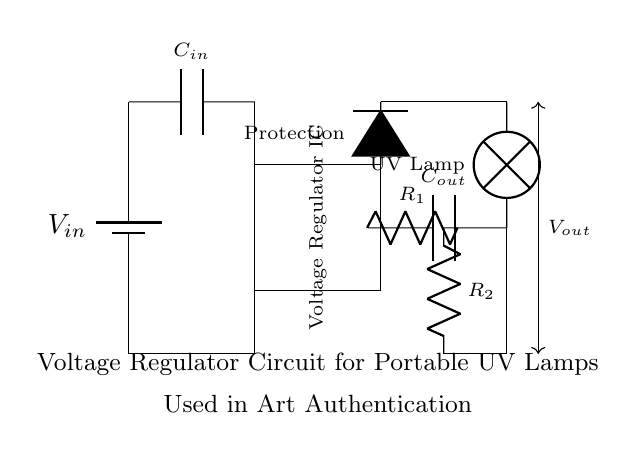What is the input voltage denoted in the circuit? The circuit indicates the input voltage as V in, which is labeled on the battery symbol at the top left.
Answer: V in What type of lamp is connected as a load in the circuit? The load is labeled as a UV lamp, which is indicated near the output side of the circuit diagram.
Answer: UV lamp What does the protection diode prevent? The protection diode serves to prevent reverse current flow, protecting the circuit from potential damage.
Answer: Reverse current How many resistors are present in the feedback loop? There are two resistors present in the feedback loop, labeled R1 and R2, connected between the output and ground.
Answer: Two What is the purpose of the capacitors in this circuit? The input capacitor C in stabilizes the input voltage, while the output capacitor C out smoothens the output by filtering.
Answer: Stabilization and filtering What is the output voltage denoted in the circuit? The output voltage is indicated as V out, which can be found near the output capacitor and UV lamp.
Answer: V out What is the primary function of the voltage regulator IC in this circuit? The voltage regulator IC is responsible for maintaining a steady output voltage despite variations in input voltage and load conditions.
Answer: Maintain steady output voltage 